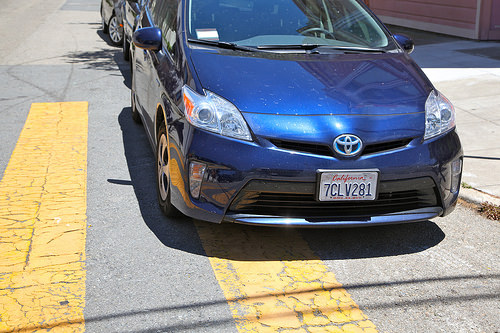<image>
Can you confirm if the car is to the right of the sidewalk? No. The car is not to the right of the sidewalk. The horizontal positioning shows a different relationship. 